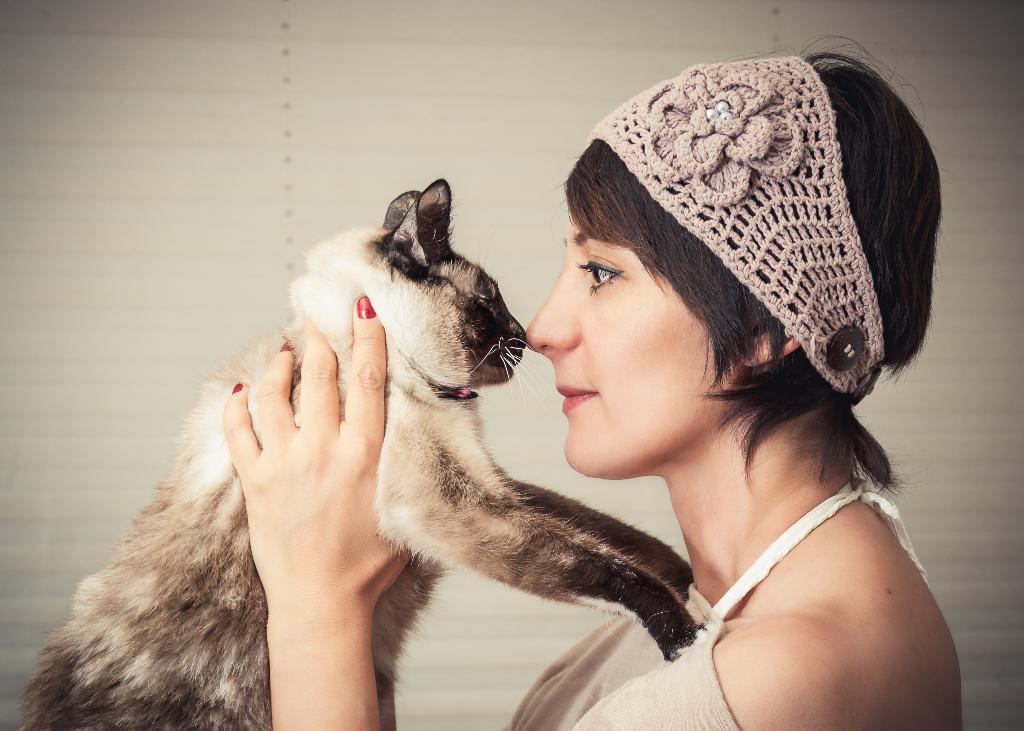Can you describe this image briefly? In this image I can see a person holding the cat. 